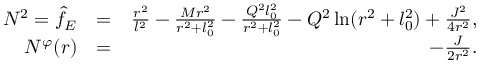<formula> <loc_0><loc_0><loc_500><loc_500>\begin{array} { r l r } { N ^ { 2 } = \hat { f } _ { E } } & { = } & { \frac { r ^ { 2 } } { l ^ { 2 } } - \frac { M r ^ { 2 } } { r ^ { 2 } + l _ { 0 } ^ { 2 } } - \frac { Q ^ { 2 } l _ { 0 } ^ { 2 } } { r ^ { 2 } + l _ { 0 } ^ { 2 } } - Q ^ { 2 } \ln ( r ^ { 2 } + l _ { 0 } ^ { 2 } ) + { \frac { J ^ { 2 } } { 4 r ^ { 2 } } } , } \\ { N ^ { \varphi } ( r ) } & { = } & { - { \frac { J } { 2 r ^ { 2 } } } . } \end{array}</formula> 